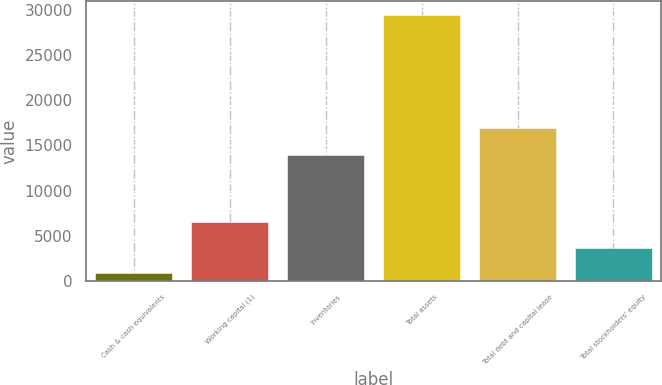Convert chart. <chart><loc_0><loc_0><loc_500><loc_500><bar_chart><fcel>Cash & cash equivalents<fcel>Working capital (1)<fcel>Inventories<fcel>Total assets<fcel>Total debt and capital lease<fcel>Total stockholders' equity<nl><fcel>794<fcel>6540<fcel>13905<fcel>29524<fcel>16976<fcel>3667<nl></chart> 